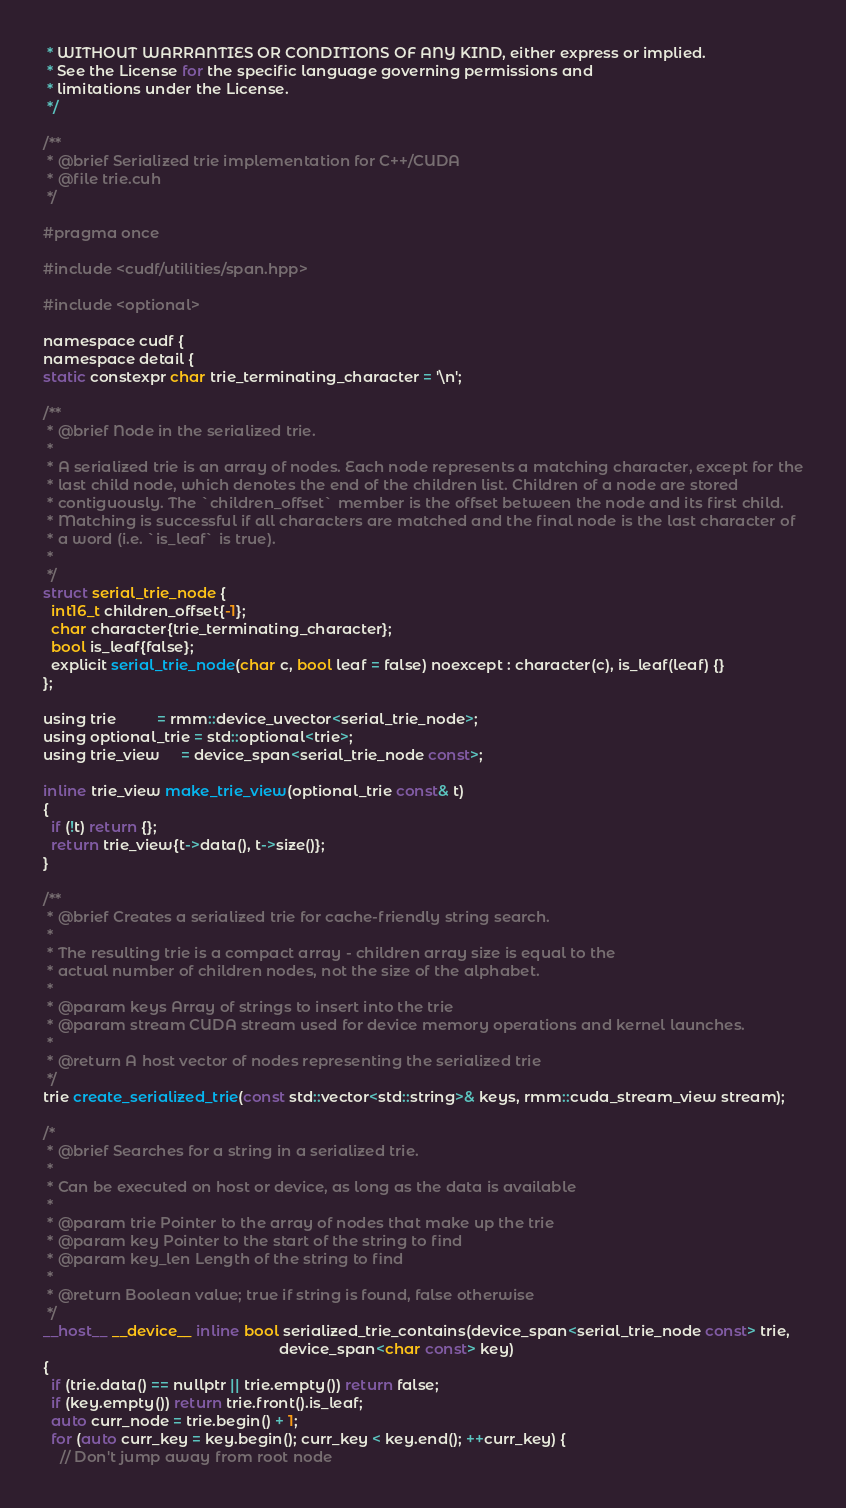<code> <loc_0><loc_0><loc_500><loc_500><_Cuda_> * WITHOUT WARRANTIES OR CONDITIONS OF ANY KIND, either express or implied.
 * See the License for the specific language governing permissions and
 * limitations under the License.
 */

/**
 * @brief Serialized trie implementation for C++/CUDA
 * @file trie.cuh
 */

#pragma once

#include <cudf/utilities/span.hpp>

#include <optional>

namespace cudf {
namespace detail {
static constexpr char trie_terminating_character = '\n';

/**
 * @brief Node in the serialized trie.
 *
 * A serialized trie is an array of nodes. Each node represents a matching character, except for the
 * last child node, which denotes the end of the children list. Children of a node are stored
 * contiguously. The `children_offset` member is the offset between the node and its first child.
 * Matching is successful if all characters are matched and the final node is the last character of
 * a word (i.e. `is_leaf` is true).
 *
 */
struct serial_trie_node {
  int16_t children_offset{-1};
  char character{trie_terminating_character};
  bool is_leaf{false};
  explicit serial_trie_node(char c, bool leaf = false) noexcept : character(c), is_leaf(leaf) {}
};

using trie          = rmm::device_uvector<serial_trie_node>;
using optional_trie = std::optional<trie>;
using trie_view     = device_span<serial_trie_node const>;

inline trie_view make_trie_view(optional_trie const& t)
{
  if (!t) return {};
  return trie_view{t->data(), t->size()};
}

/**
 * @brief Creates a serialized trie for cache-friendly string search.
 *
 * The resulting trie is a compact array - children array size is equal to the
 * actual number of children nodes, not the size of the alphabet.
 *
 * @param keys Array of strings to insert into the trie
 * @param stream CUDA stream used for device memory operations and kernel launches.
 *
 * @return A host vector of nodes representing the serialized trie
 */
trie create_serialized_trie(const std::vector<std::string>& keys, rmm::cuda_stream_view stream);

/*
 * @brief Searches for a string in a serialized trie.
 *
 * Can be executed on host or device, as long as the data is available
 *
 * @param trie Pointer to the array of nodes that make up the trie
 * @param key Pointer to the start of the string to find
 * @param key_len Length of the string to find
 *
 * @return Boolean value; true if string is found, false otherwise
 */
__host__ __device__ inline bool serialized_trie_contains(device_span<serial_trie_node const> trie,
                                                         device_span<char const> key)
{
  if (trie.data() == nullptr || trie.empty()) return false;
  if (key.empty()) return trie.front().is_leaf;
  auto curr_node = trie.begin() + 1;
  for (auto curr_key = key.begin(); curr_key < key.end(); ++curr_key) {
    // Don't jump away from root node</code> 